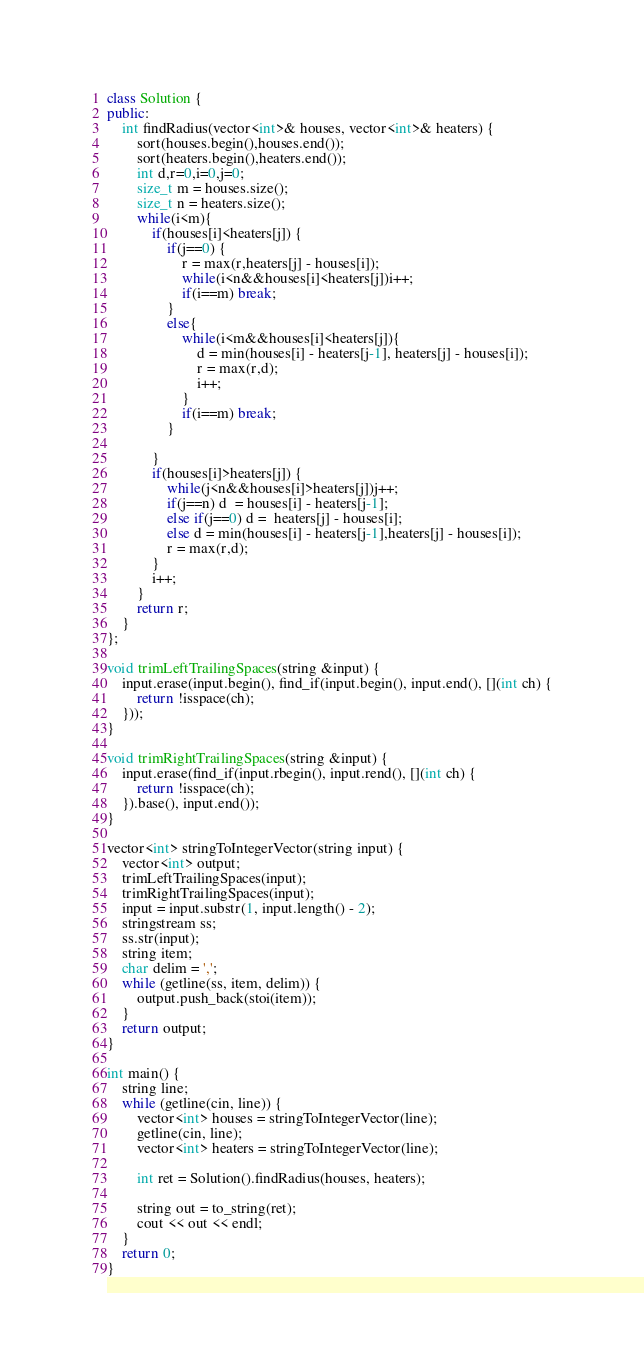<code> <loc_0><loc_0><loc_500><loc_500><_C++_>class Solution {
public:
    int findRadius(vector<int>& houses, vector<int>& heaters) {
        sort(houses.begin(),houses.end());
        sort(heaters.begin(),heaters.end());
        int d,r=0,i=0,j=0;
        size_t m = houses.size();
        size_t n = heaters.size();
        while(i<m){
            if(houses[i]<heaters[j]) {
                if(j==0) {
                    r = max(r,heaters[j] - houses[i]);
                    while(i<n&&houses[i]<heaters[j])i++;
                    if(i==m) break;
                } 
                else{
                    while(i<m&&houses[i]<heaters[j]){
                        d = min(houses[i] - heaters[j-1], heaters[j] - houses[i]);
                        r = max(r,d);
                        i++;                        
                    }
                    if(i==m) break;    
                }
                
            }
            if(houses[i]>heaters[j]) {
                while(j<n&&houses[i]>heaters[j])j++;
                if(j==n) d  = houses[i] - heaters[j-1];
                else if(j==0) d =  heaters[j] - houses[i];
                else d = min(houses[i] - heaters[j-1],heaters[j] - houses[i]);
                r = max(r,d);
            }
            i++;
        }
        return r;
    }
};

void trimLeftTrailingSpaces(string &input) {
    input.erase(input.begin(), find_if(input.begin(), input.end(), [](int ch) {
        return !isspace(ch);
    }));
}

void trimRightTrailingSpaces(string &input) {
    input.erase(find_if(input.rbegin(), input.rend(), [](int ch) {
        return !isspace(ch);
    }).base(), input.end());
}

vector<int> stringToIntegerVector(string input) {
    vector<int> output;
    trimLeftTrailingSpaces(input);
    trimRightTrailingSpaces(input);
    input = input.substr(1, input.length() - 2);
    stringstream ss;
    ss.str(input);
    string item;
    char delim = ',';
    while (getline(ss, item, delim)) {
        output.push_back(stoi(item));
    }
    return output;
}

int main() {
    string line;
    while (getline(cin, line)) {
        vector<int> houses = stringToIntegerVector(line);
        getline(cin, line);
        vector<int> heaters = stringToIntegerVector(line);
        
        int ret = Solution().findRadius(houses, heaters);

        string out = to_string(ret);
        cout << out << endl;
    }
    return 0;
}
</code> 